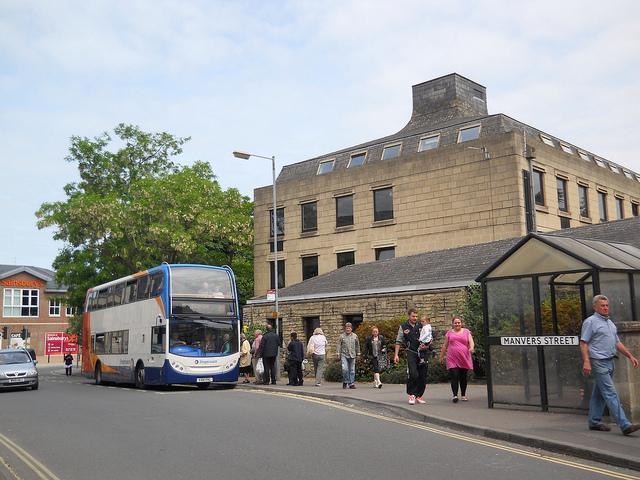When was the first bus stop installed?
Pick the right solution, then justify: 'Answer: answer
Rationale: rationale.'
Options: 1820s, 1840s, 1860s, 1850s. Answer: 1820s.
Rationale: The very first bus route opened on 4 july 1829. 